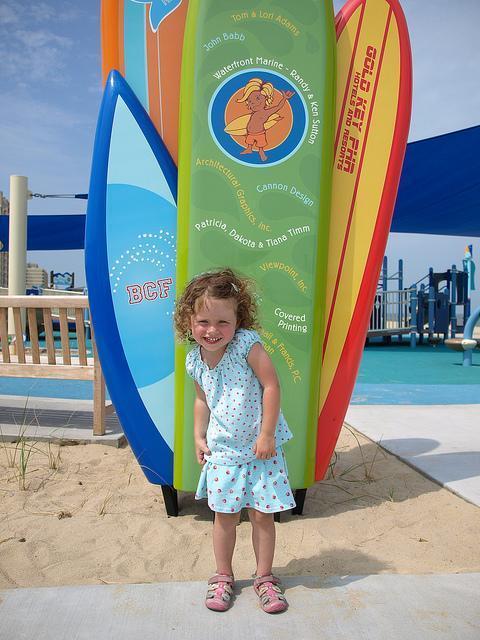How many surfboards are visible?
Give a very brief answer. 4. 